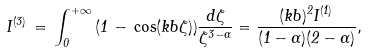Convert formula to latex. <formula><loc_0><loc_0><loc_500><loc_500>I ^ { ( 3 ) } \, = \, \int _ { 0 } ^ { + \infty } \, ( 1 \, - \, \cos ( k b \zeta ) ) \frac { d \zeta } { \zeta ^ { 3 - \alpha } } = \frac { ( k b ) ^ { 2 } I ^ { ( 1 ) } } { ( 1 - \alpha ) ( 2 - \alpha ) } ,</formula> 